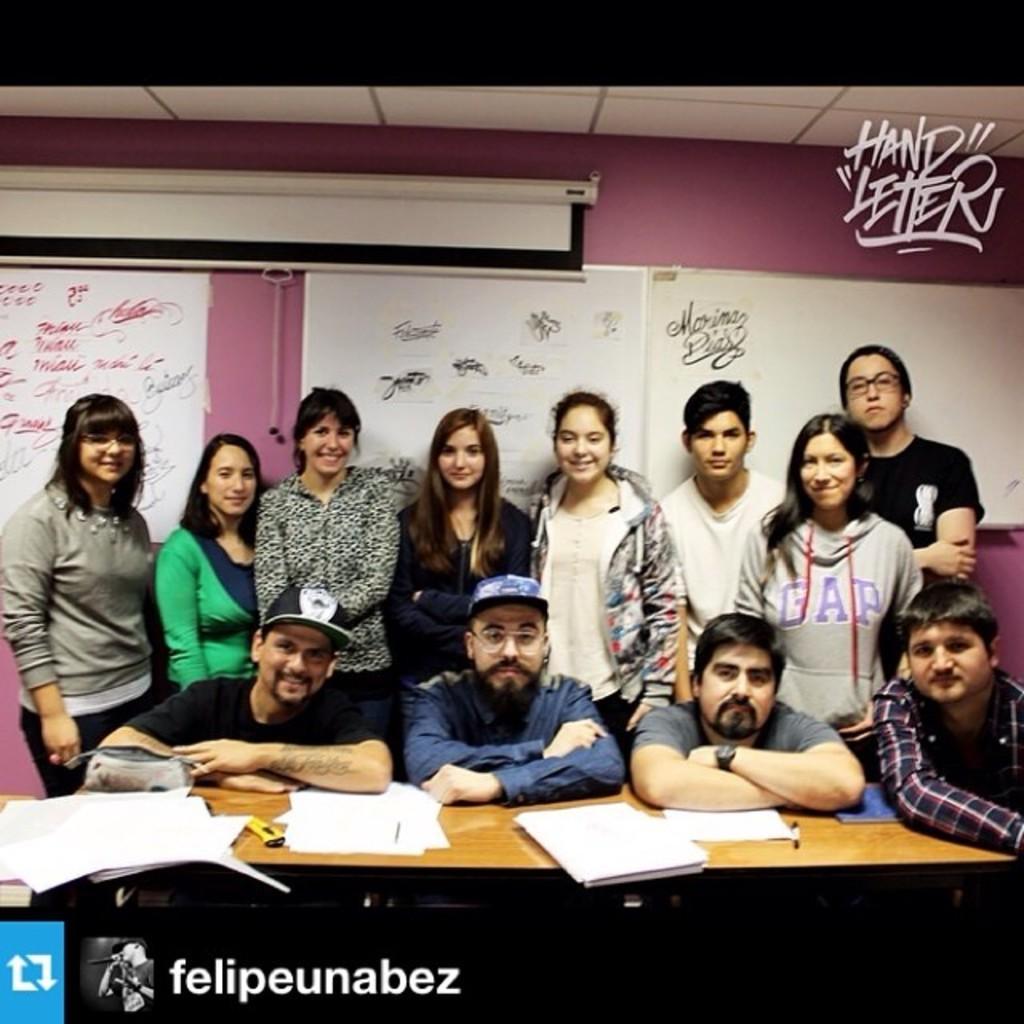How would you summarize this image in a sentence or two? In the background we can see boards and a screen board. At the top there is a ceiling. We can see people standing and giving pose to a camera. Here near to a table we can see men and on the table we can see papers. 